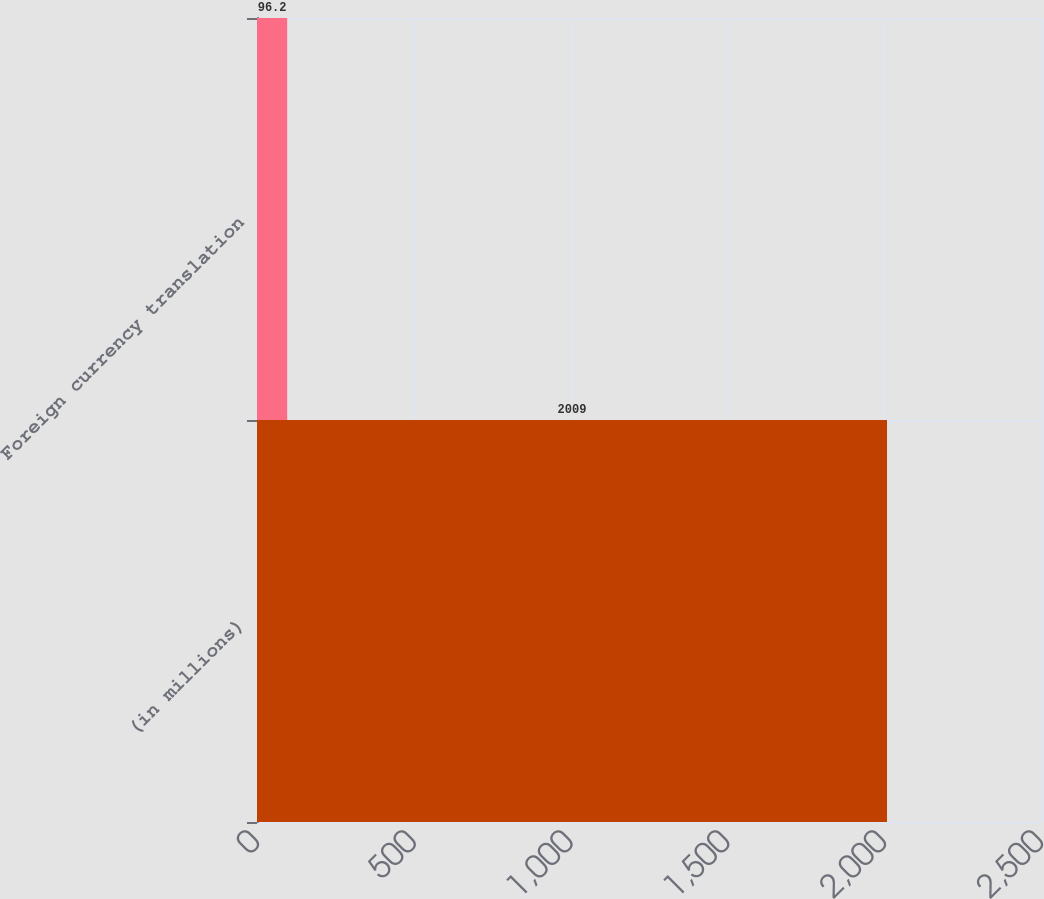<chart> <loc_0><loc_0><loc_500><loc_500><bar_chart><fcel>(in millions)<fcel>Foreign currency translation<nl><fcel>2009<fcel>96.2<nl></chart> 